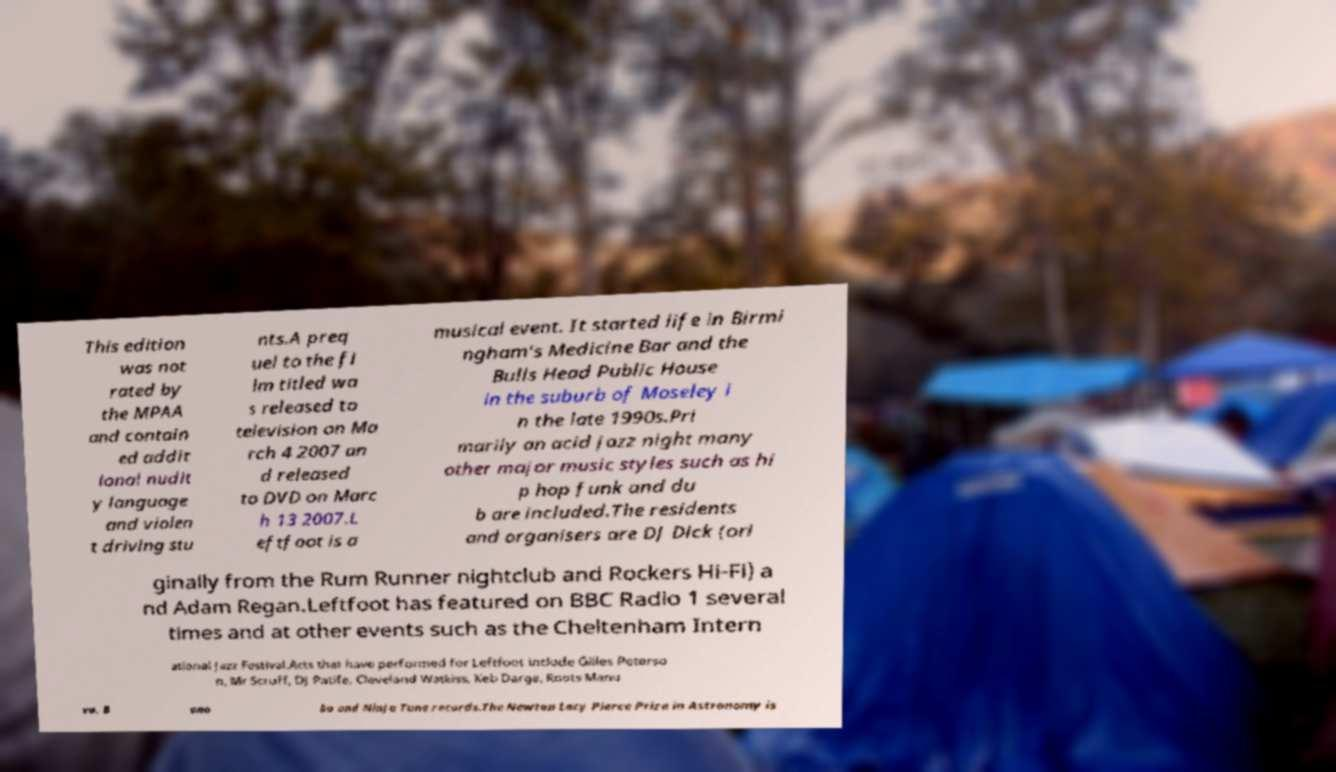Please identify and transcribe the text found in this image. This edition was not rated by the MPAA and contain ed addit ional nudit y language and violen t driving stu nts.A preq uel to the fi lm titled wa s released to television on Ma rch 4 2007 an d released to DVD on Marc h 13 2007.L eftfoot is a musical event. It started life in Birmi ngham's Medicine Bar and the Bulls Head Public House in the suburb of Moseley i n the late 1990s.Pri marily an acid jazz night many other major music styles such as hi p hop funk and du b are included.The residents and organisers are DJ Dick (ori ginally from the Rum Runner nightclub and Rockers Hi-Fi) a nd Adam Regan.Leftfoot has featured on BBC Radio 1 several times and at other events such as the Cheltenham Intern ational Jazz Festival.Acts that have performed for Leftfoot include Gilles Peterso n, Mr Scruff, DJ Patife, Cleveland Watkiss, Keb Darge, Roots Manu va, B ono bo and Ninja Tune records.The Newton Lacy Pierce Prize in Astronomy is 